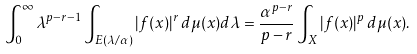<formula> <loc_0><loc_0><loc_500><loc_500>\int _ { 0 } ^ { \infty } \lambda ^ { p - r - 1 } \int _ { E ( \lambda / \alpha ) } | f ( x ) | ^ { r } \, d \mu ( x ) d \lambda = \frac { \alpha ^ { p - r } } { p - r } \int _ { X } | f ( x ) | ^ { p } \, d \mu ( x ) .</formula> 